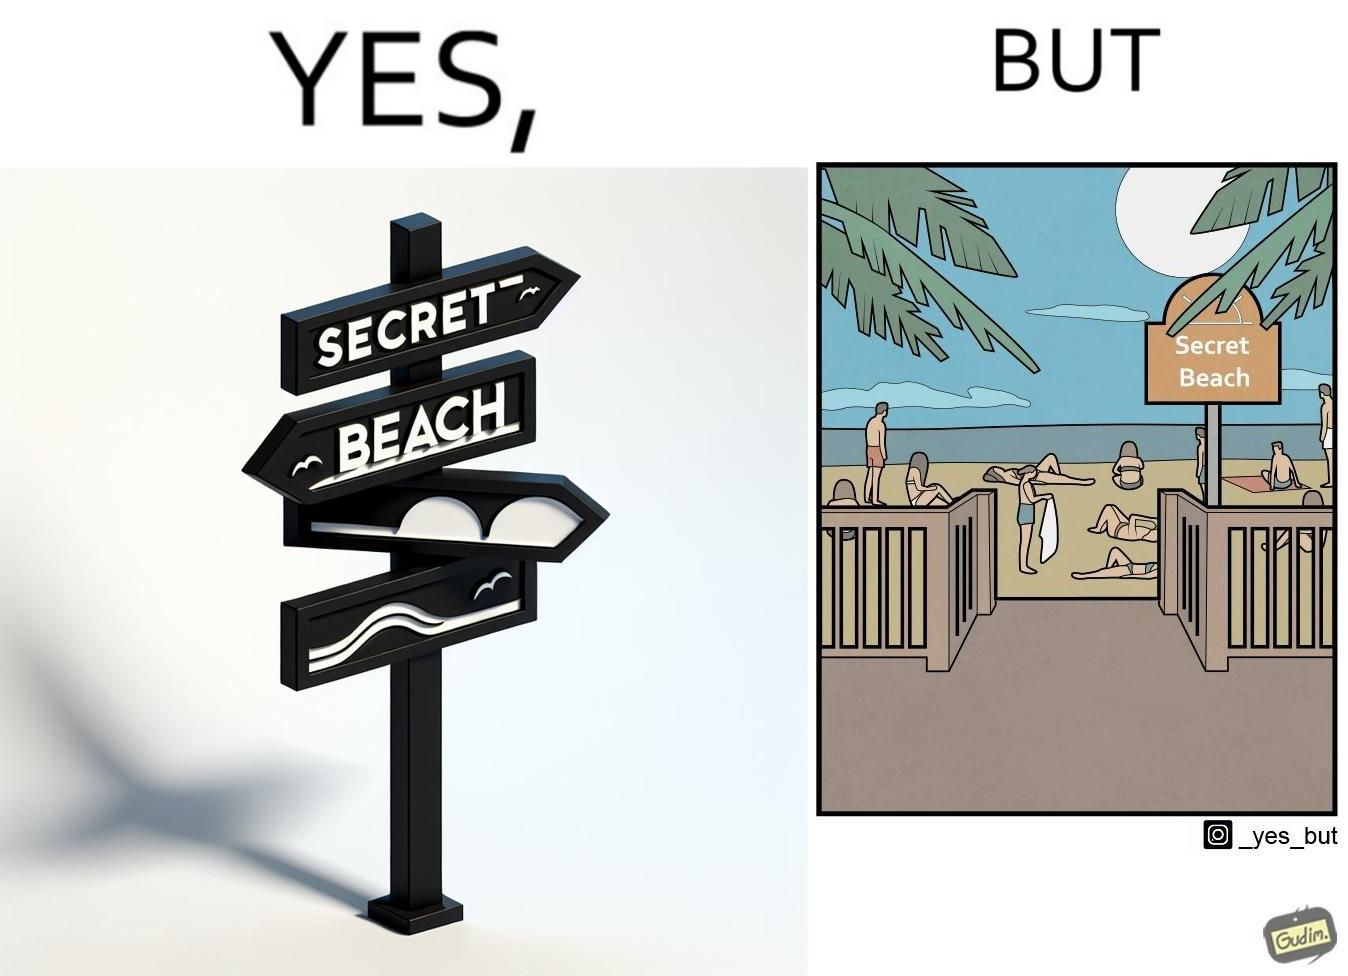Describe what you see in the left and right parts of this image. In the left part of the image: A board with "Secret Beach" written on it. In the right part of the image: People in a beach, having a board with "Secret Beach" written on it at its entrance. 